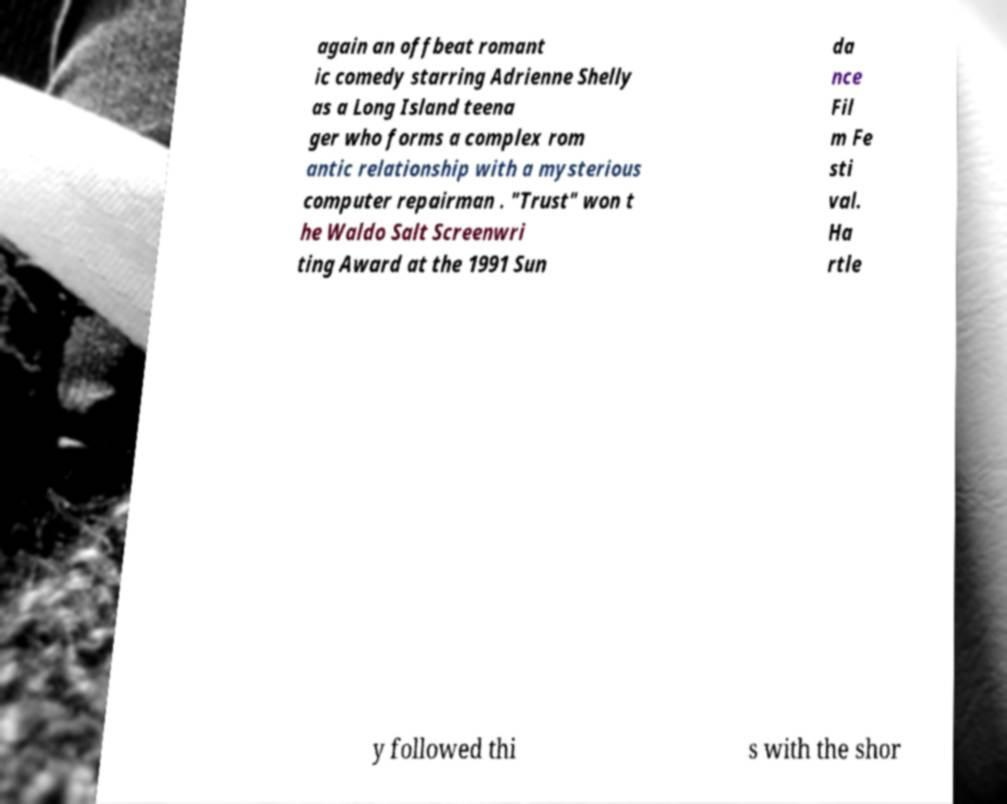Please read and relay the text visible in this image. What does it say? again an offbeat romant ic comedy starring Adrienne Shelly as a Long Island teena ger who forms a complex rom antic relationship with a mysterious computer repairman . "Trust" won t he Waldo Salt Screenwri ting Award at the 1991 Sun da nce Fil m Fe sti val. Ha rtle y followed thi s with the shor 